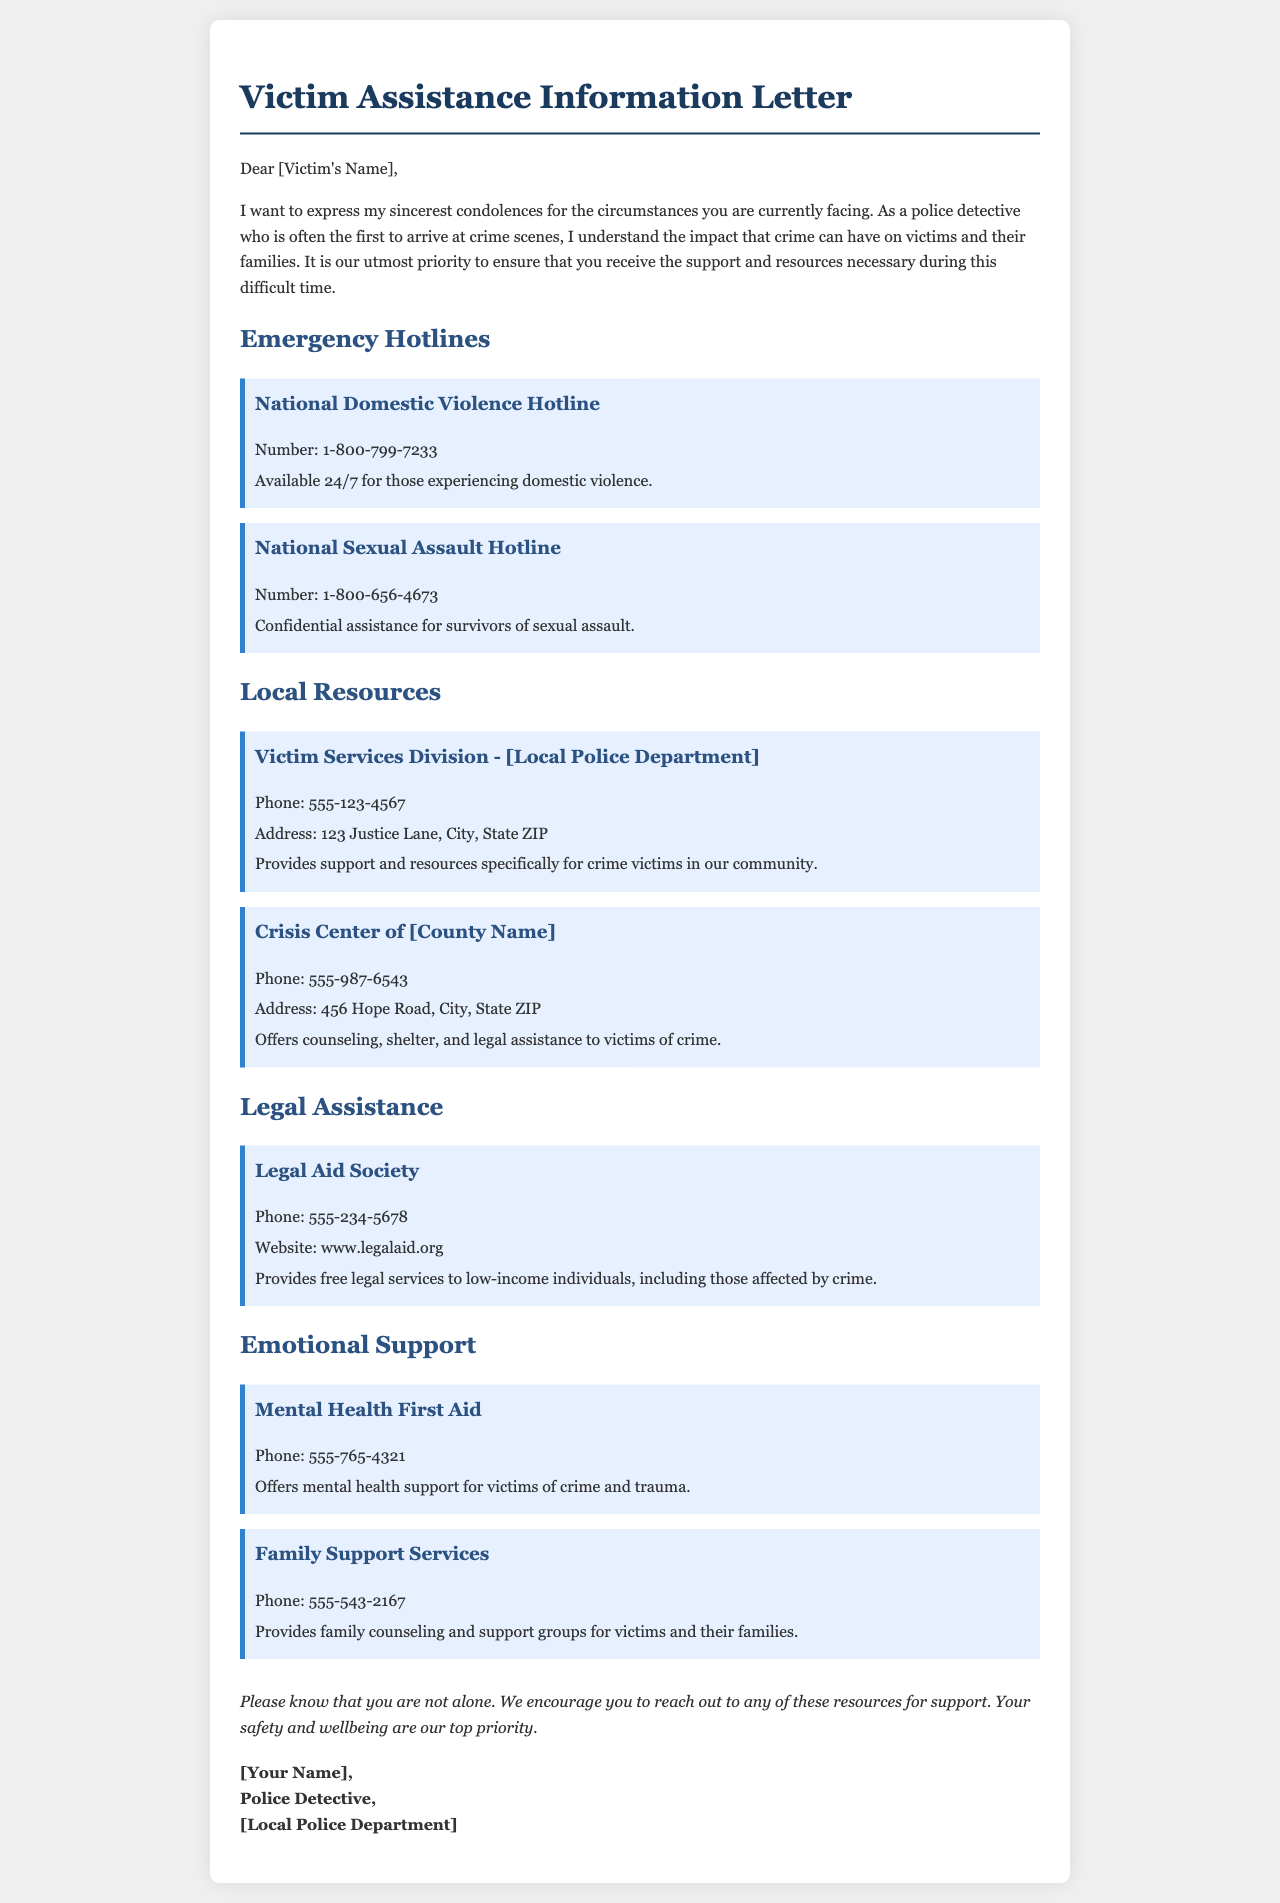what is the hotline number for domestic violence? The document states the hotline number for domestic violence is provided in the resource section under the National Domestic Violence Hotline.
Answer: 1-800-799-7233 what service does the Crisis Center of [County Name] provide? The document describes the services offered by the Crisis Center of [County Name] in the "Local Resources" section.
Answer: Counseling, shelter, and legal assistance who is the letter addressed to? The letter begins with a salutation addressing the recipient.
Answer: [Victim's Name] what is the purpose of the Legal Aid Society? The document explains the focus of the Legal Aid Society in the "Legal Assistance" section.
Answer: Free legal services to low-income individuals which organization provides mental health support for crime victims? The document specifies the organization that offers mental health support in the "Emotional Support" section.
Answer: Mental Health First Aid what is the phone number for the Victim Services Division? The phone number of the Victim Services Division can be found in the "Local Resources" section of the letter.
Answer: 555-123-4567 how does the document express support for the victim? The letter conveys support through its concluding remarks encouraging the victim to reach out for help.
Answer: You are not alone which department is mentioned as the sender of the letter? The signature section of the document identifies the department associated with the sender.
Answer: [Local Police Department] 